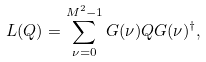Convert formula to latex. <formula><loc_0><loc_0><loc_500><loc_500>L ( Q ) = \sum _ { \nu = 0 } ^ { M ^ { 2 } - 1 } G ( \nu ) Q G ( \nu ) ^ { \dagger } ,</formula> 